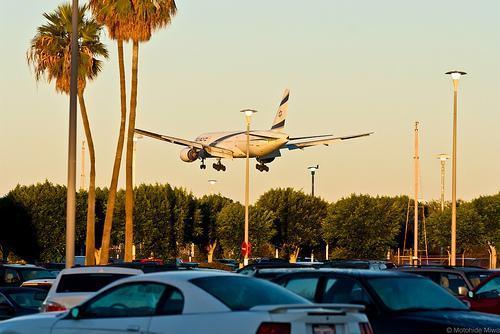How many palm trees are in the parking lot?
Give a very brief answer. 3. How many airplanes are pictured?
Give a very brief answer. 1. How many blue airplane are flying?
Give a very brief answer. 0. 